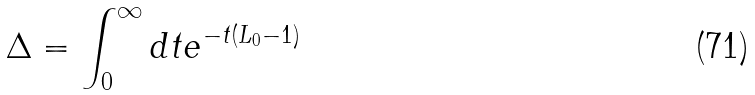Convert formula to latex. <formula><loc_0><loc_0><loc_500><loc_500>\Delta = \int _ { 0 } ^ { \infty } d t e ^ { - t ( L _ { 0 } - 1 ) }</formula> 